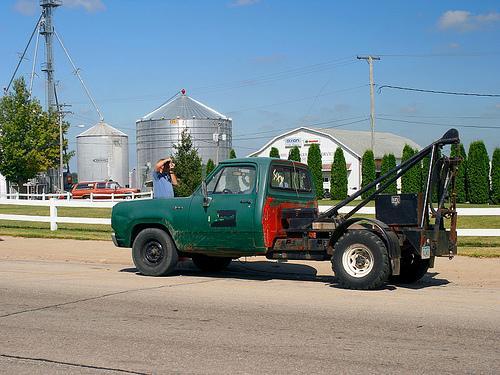Is this a tow truck?
Write a very short answer. Yes. What is the truck on top of?
Short answer required. Road. What color is the fence?
Be succinct. White. 